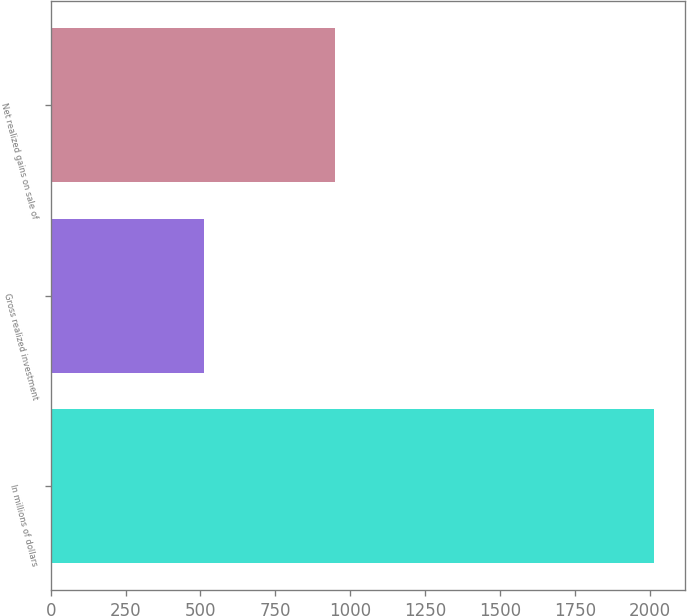Convert chart to OTSL. <chart><loc_0><loc_0><loc_500><loc_500><bar_chart><fcel>In millions of dollars<fcel>Gross realized investment<fcel>Net realized gains on sale of<nl><fcel>2016<fcel>511<fcel>949<nl></chart> 